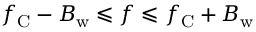Convert formula to latex. <formula><loc_0><loc_0><loc_500><loc_500>f _ { C } - B _ { w } \leqslant f \leqslant f _ { C } + B _ { w }</formula> 